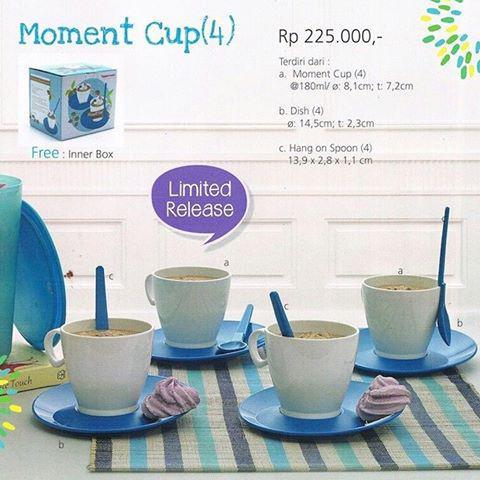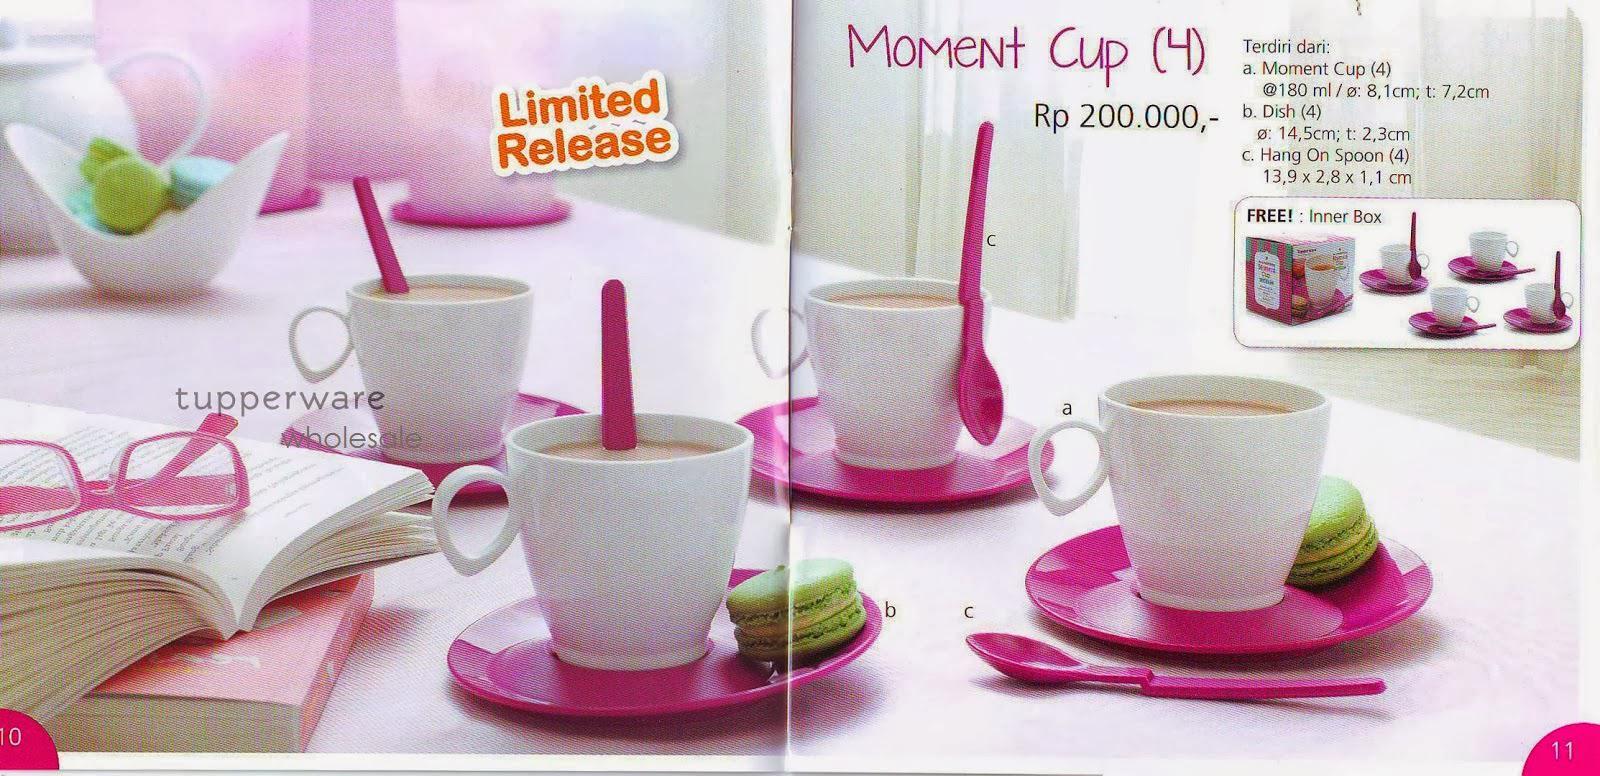The first image is the image on the left, the second image is the image on the right. Analyze the images presented: Is the assertion "Pink transparent cups are on the left image." valid? Answer yes or no. No. 